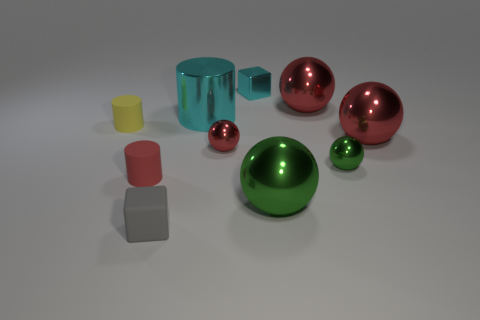How many things are either shiny cubes or matte things that are right of the yellow thing?
Provide a succinct answer. 3. There is a green metallic ball that is left of the small green metal object; is it the same size as the cyan thing that is right of the metallic cylinder?
Provide a short and direct response. No. How many other objects are the same color as the metallic block?
Keep it short and to the point. 1. Do the yellow cylinder and the matte cylinder right of the small yellow cylinder have the same size?
Your answer should be compact. Yes. What is the size of the red metallic thing that is on the left side of the large red ball on the left side of the small green thing?
Keep it short and to the point. Small. There is another thing that is the same shape as the tiny cyan metallic object; what color is it?
Offer a terse response. Gray. Do the cyan metallic cylinder and the cyan cube have the same size?
Make the answer very short. No. Are there the same number of tiny green things that are behind the big shiny cylinder and red things?
Your answer should be very brief. No. Is there a cube behind the small gray thing that is right of the small yellow thing?
Offer a terse response. Yes. There is a block that is right of the cylinder that is on the right side of the small red thing on the left side of the gray rubber thing; what size is it?
Keep it short and to the point. Small. 